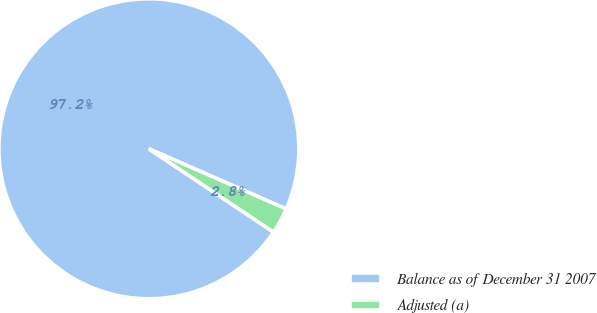Convert chart to OTSL. <chart><loc_0><loc_0><loc_500><loc_500><pie_chart><fcel>Balance as of December 31 2007<fcel>Adjusted (a)<nl><fcel>97.2%<fcel>2.8%<nl></chart> 